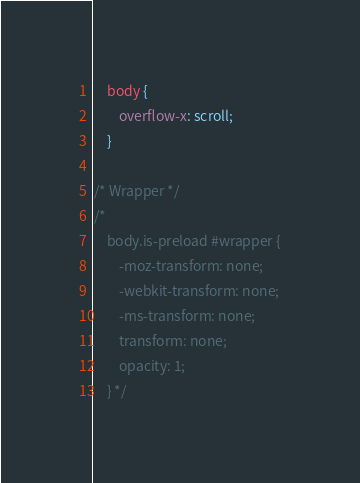<code> <loc_0><loc_0><loc_500><loc_500><_CSS_>	body {
		overflow-x: scroll;
	}

/* Wrapper */
/*
	body.is-preload #wrapper {
		-moz-transform: none;
		-webkit-transform: none;
		-ms-transform: none;
		transform: none;
		opacity: 1;
	} */</code> 